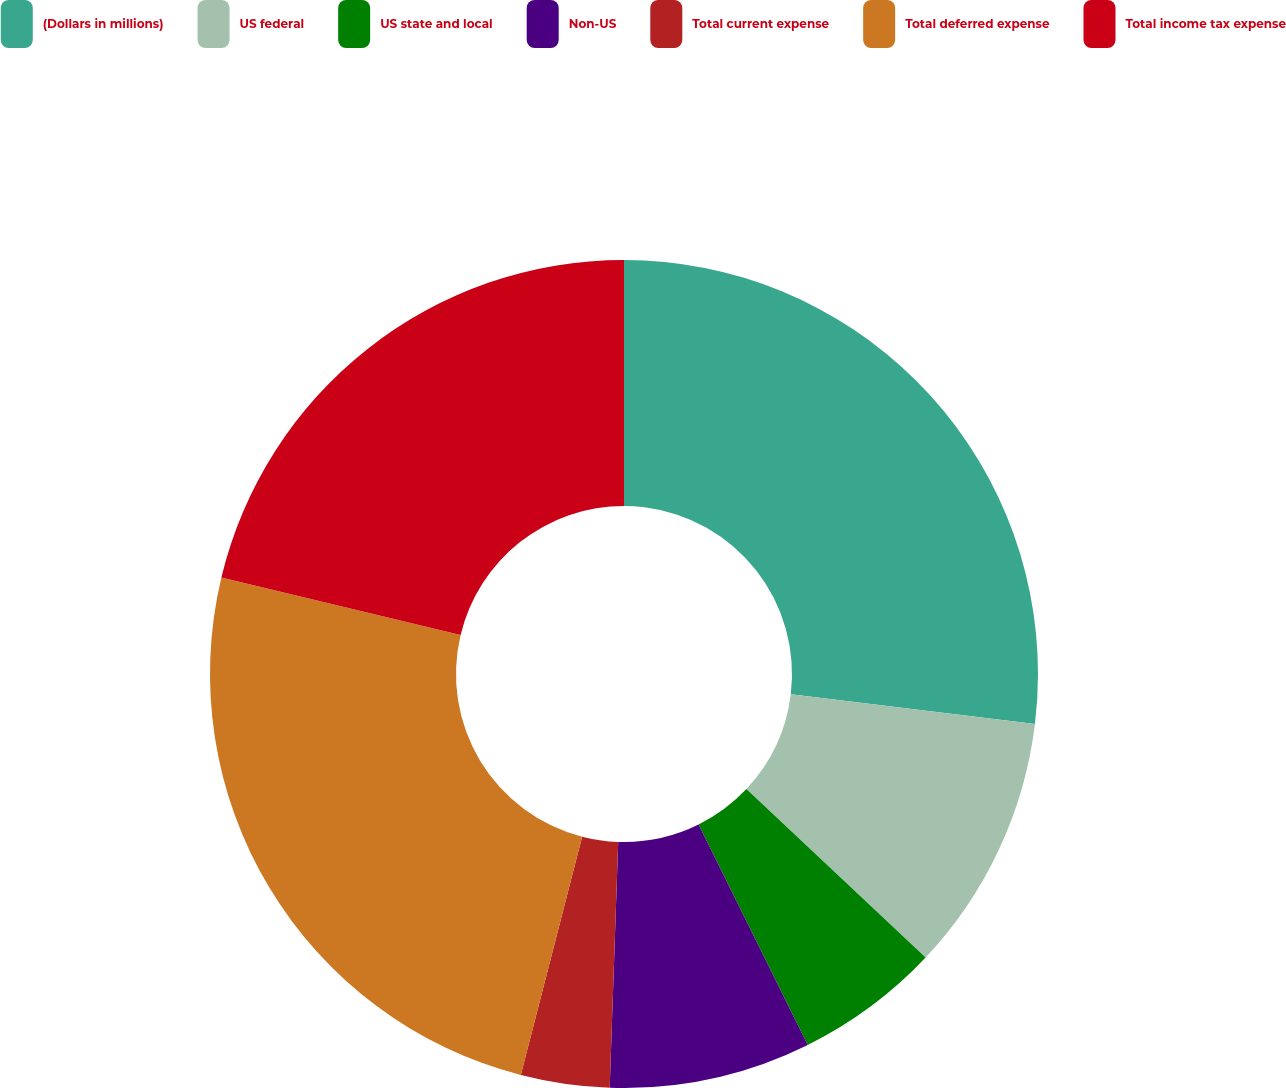<chart> <loc_0><loc_0><loc_500><loc_500><pie_chart><fcel>(Dollars in millions)<fcel>US federal<fcel>US state and local<fcel>Non-US<fcel>Total current expense<fcel>Total deferred expense<fcel>Total income tax expense<nl><fcel>26.93%<fcel>10.08%<fcel>5.67%<fcel>7.87%<fcel>3.46%<fcel>24.73%<fcel>21.26%<nl></chart> 